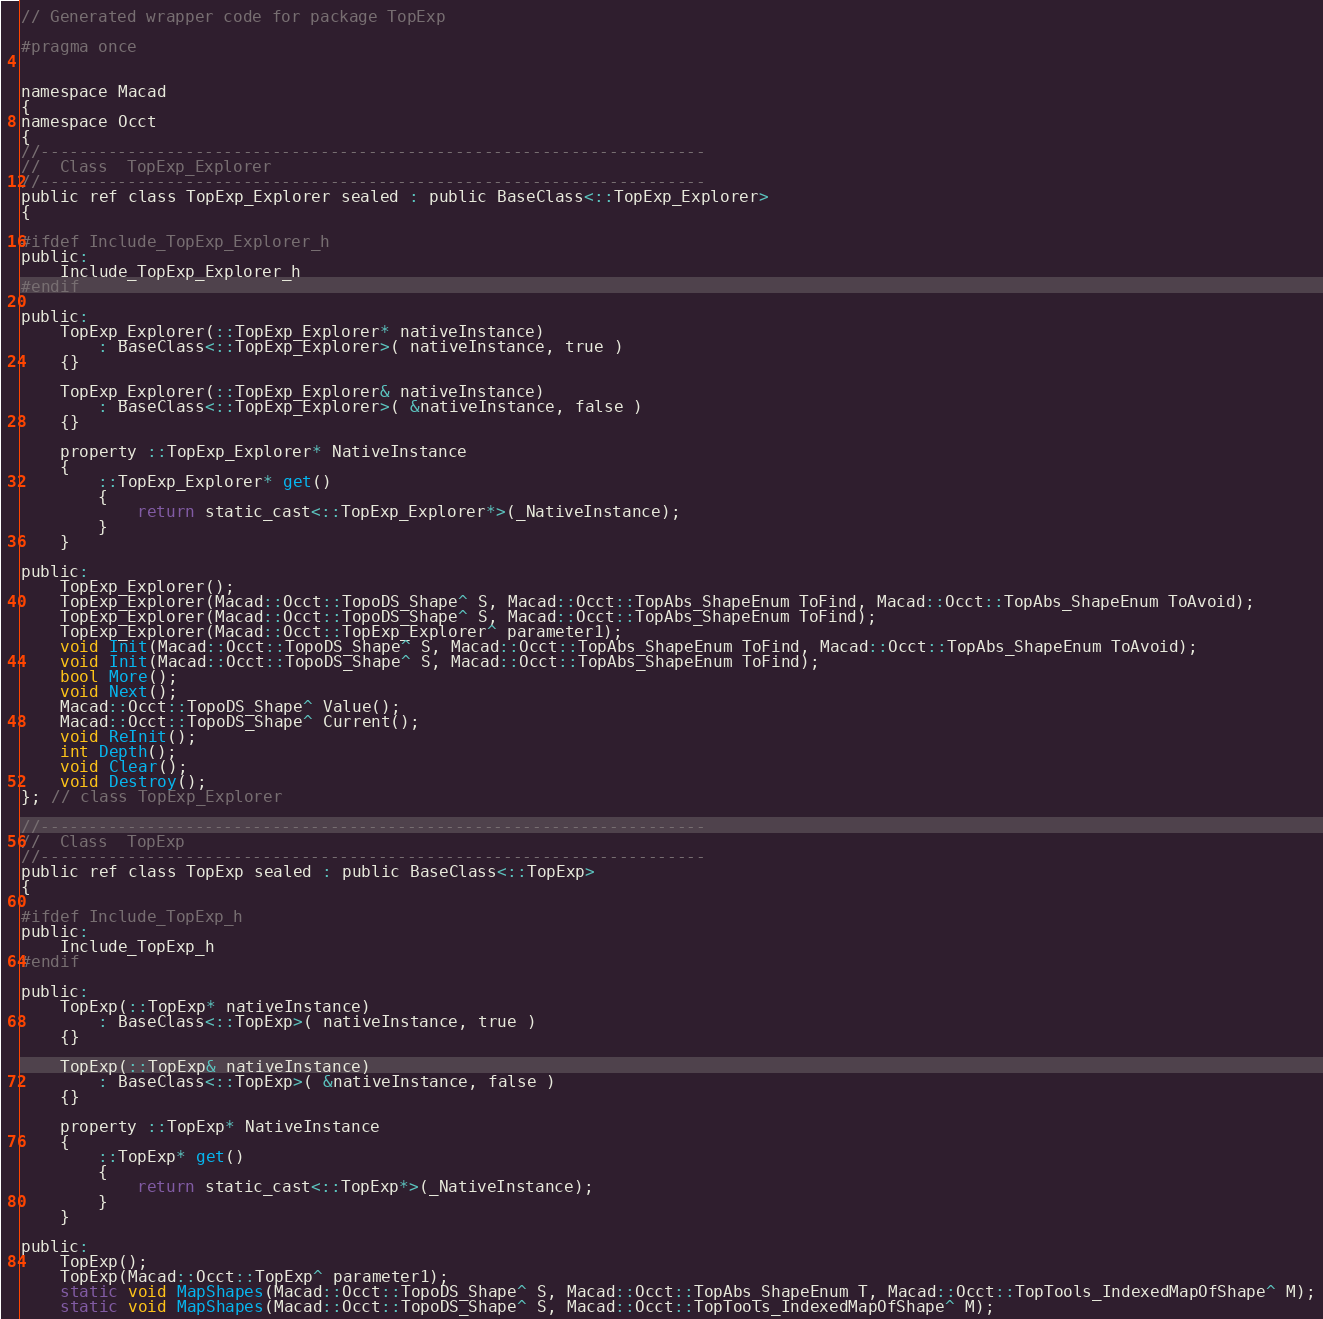Convert code to text. <code><loc_0><loc_0><loc_500><loc_500><_C_>// Generated wrapper code for package TopExp

#pragma once


namespace Macad
{
namespace Occt
{
//---------------------------------------------------------------------
//  Class  TopExp_Explorer
//---------------------------------------------------------------------
public ref class TopExp_Explorer sealed : public BaseClass<::TopExp_Explorer>
{

#ifdef Include_TopExp_Explorer_h
public:
	Include_TopExp_Explorer_h
#endif

public:
	TopExp_Explorer(::TopExp_Explorer* nativeInstance)
		: BaseClass<::TopExp_Explorer>( nativeInstance, true )
	{}

	TopExp_Explorer(::TopExp_Explorer& nativeInstance)
		: BaseClass<::TopExp_Explorer>( &nativeInstance, false )
	{}

	property ::TopExp_Explorer* NativeInstance
	{
		::TopExp_Explorer* get()
		{
			return static_cast<::TopExp_Explorer*>(_NativeInstance);
		}
	}

public:
	TopExp_Explorer();
	TopExp_Explorer(Macad::Occt::TopoDS_Shape^ S, Macad::Occt::TopAbs_ShapeEnum ToFind, Macad::Occt::TopAbs_ShapeEnum ToAvoid);
	TopExp_Explorer(Macad::Occt::TopoDS_Shape^ S, Macad::Occt::TopAbs_ShapeEnum ToFind);
	TopExp_Explorer(Macad::Occt::TopExp_Explorer^ parameter1);
	void Init(Macad::Occt::TopoDS_Shape^ S, Macad::Occt::TopAbs_ShapeEnum ToFind, Macad::Occt::TopAbs_ShapeEnum ToAvoid);
	void Init(Macad::Occt::TopoDS_Shape^ S, Macad::Occt::TopAbs_ShapeEnum ToFind);
	bool More();
	void Next();
	Macad::Occt::TopoDS_Shape^ Value();
	Macad::Occt::TopoDS_Shape^ Current();
	void ReInit();
	int Depth();
	void Clear();
	void Destroy();
}; // class TopExp_Explorer

//---------------------------------------------------------------------
//  Class  TopExp
//---------------------------------------------------------------------
public ref class TopExp sealed : public BaseClass<::TopExp>
{

#ifdef Include_TopExp_h
public:
	Include_TopExp_h
#endif

public:
	TopExp(::TopExp* nativeInstance)
		: BaseClass<::TopExp>( nativeInstance, true )
	{}

	TopExp(::TopExp& nativeInstance)
		: BaseClass<::TopExp>( &nativeInstance, false )
	{}

	property ::TopExp* NativeInstance
	{
		::TopExp* get()
		{
			return static_cast<::TopExp*>(_NativeInstance);
		}
	}

public:
	TopExp();
	TopExp(Macad::Occt::TopExp^ parameter1);
	static void MapShapes(Macad::Occt::TopoDS_Shape^ S, Macad::Occt::TopAbs_ShapeEnum T, Macad::Occt::TopTools_IndexedMapOfShape^ M);
	static void MapShapes(Macad::Occt::TopoDS_Shape^ S, Macad::Occt::TopTools_IndexedMapOfShape^ M);</code> 